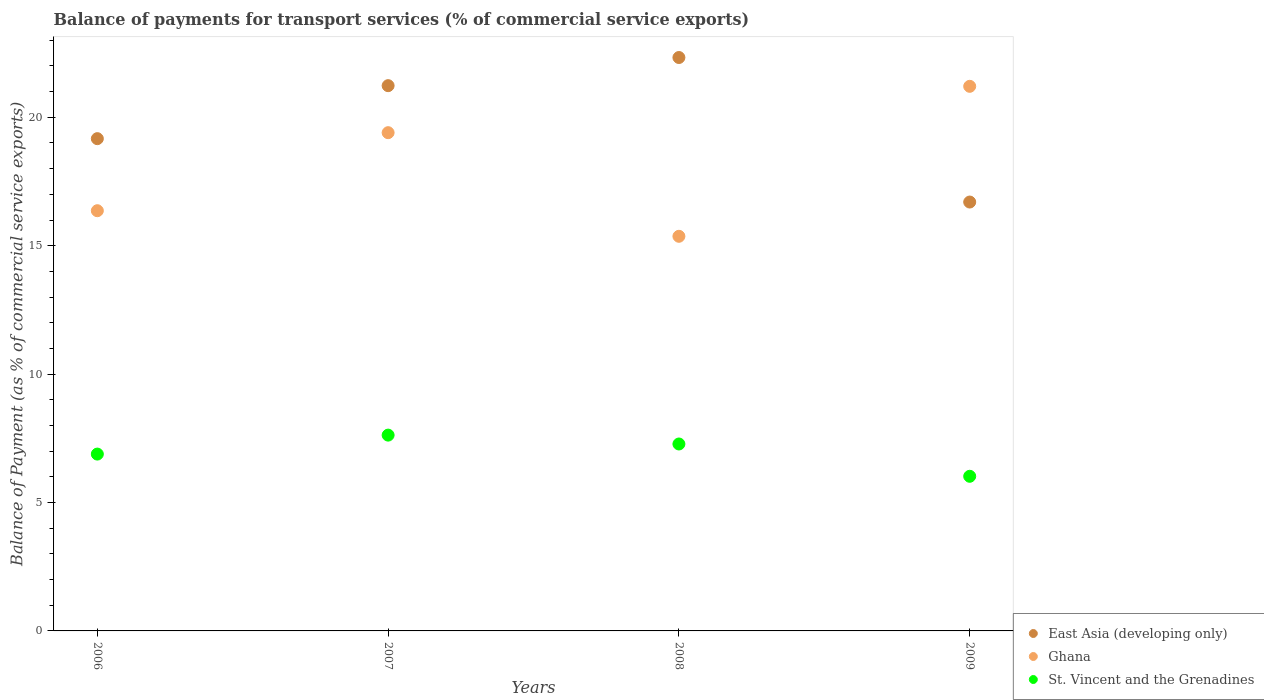How many different coloured dotlines are there?
Your response must be concise. 3. What is the balance of payments for transport services in East Asia (developing only) in 2007?
Give a very brief answer. 21.23. Across all years, what is the maximum balance of payments for transport services in Ghana?
Make the answer very short. 21.21. Across all years, what is the minimum balance of payments for transport services in East Asia (developing only)?
Provide a succinct answer. 16.7. In which year was the balance of payments for transport services in East Asia (developing only) maximum?
Your response must be concise. 2008. In which year was the balance of payments for transport services in Ghana minimum?
Ensure brevity in your answer.  2008. What is the total balance of payments for transport services in East Asia (developing only) in the graph?
Provide a short and direct response. 79.43. What is the difference between the balance of payments for transport services in East Asia (developing only) in 2006 and that in 2007?
Offer a very short reply. -2.06. What is the difference between the balance of payments for transport services in St. Vincent and the Grenadines in 2006 and the balance of payments for transport services in Ghana in 2008?
Offer a very short reply. -8.48. What is the average balance of payments for transport services in Ghana per year?
Offer a terse response. 18.08. In the year 2007, what is the difference between the balance of payments for transport services in Ghana and balance of payments for transport services in St. Vincent and the Grenadines?
Your answer should be very brief. 11.78. What is the ratio of the balance of payments for transport services in St. Vincent and the Grenadines in 2006 to that in 2009?
Your answer should be very brief. 1.14. Is the difference between the balance of payments for transport services in Ghana in 2006 and 2007 greater than the difference between the balance of payments for transport services in St. Vincent and the Grenadines in 2006 and 2007?
Offer a terse response. No. What is the difference between the highest and the second highest balance of payments for transport services in Ghana?
Keep it short and to the point. 1.81. What is the difference between the highest and the lowest balance of payments for transport services in Ghana?
Make the answer very short. 5.84. In how many years, is the balance of payments for transport services in East Asia (developing only) greater than the average balance of payments for transport services in East Asia (developing only) taken over all years?
Provide a short and direct response. 2. Is the sum of the balance of payments for transport services in St. Vincent and the Grenadines in 2006 and 2008 greater than the maximum balance of payments for transport services in East Asia (developing only) across all years?
Offer a terse response. No. Is the balance of payments for transport services in St. Vincent and the Grenadines strictly greater than the balance of payments for transport services in East Asia (developing only) over the years?
Provide a succinct answer. No. What is the difference between two consecutive major ticks on the Y-axis?
Ensure brevity in your answer.  5. Are the values on the major ticks of Y-axis written in scientific E-notation?
Give a very brief answer. No. Where does the legend appear in the graph?
Offer a terse response. Bottom right. What is the title of the graph?
Make the answer very short. Balance of payments for transport services (% of commercial service exports). What is the label or title of the X-axis?
Provide a succinct answer. Years. What is the label or title of the Y-axis?
Your answer should be compact. Balance of Payment (as % of commercial service exports). What is the Balance of Payment (as % of commercial service exports) of East Asia (developing only) in 2006?
Offer a very short reply. 19.17. What is the Balance of Payment (as % of commercial service exports) of Ghana in 2006?
Your answer should be very brief. 16.36. What is the Balance of Payment (as % of commercial service exports) in St. Vincent and the Grenadines in 2006?
Your response must be concise. 6.89. What is the Balance of Payment (as % of commercial service exports) of East Asia (developing only) in 2007?
Provide a short and direct response. 21.23. What is the Balance of Payment (as % of commercial service exports) of Ghana in 2007?
Your answer should be very brief. 19.4. What is the Balance of Payment (as % of commercial service exports) of St. Vincent and the Grenadines in 2007?
Keep it short and to the point. 7.62. What is the Balance of Payment (as % of commercial service exports) of East Asia (developing only) in 2008?
Provide a succinct answer. 22.33. What is the Balance of Payment (as % of commercial service exports) of Ghana in 2008?
Offer a very short reply. 15.37. What is the Balance of Payment (as % of commercial service exports) in St. Vincent and the Grenadines in 2008?
Keep it short and to the point. 7.28. What is the Balance of Payment (as % of commercial service exports) in East Asia (developing only) in 2009?
Your response must be concise. 16.7. What is the Balance of Payment (as % of commercial service exports) of Ghana in 2009?
Offer a terse response. 21.21. What is the Balance of Payment (as % of commercial service exports) of St. Vincent and the Grenadines in 2009?
Your answer should be very brief. 6.02. Across all years, what is the maximum Balance of Payment (as % of commercial service exports) of East Asia (developing only)?
Ensure brevity in your answer.  22.33. Across all years, what is the maximum Balance of Payment (as % of commercial service exports) of Ghana?
Provide a short and direct response. 21.21. Across all years, what is the maximum Balance of Payment (as % of commercial service exports) of St. Vincent and the Grenadines?
Provide a succinct answer. 7.62. Across all years, what is the minimum Balance of Payment (as % of commercial service exports) in East Asia (developing only)?
Provide a short and direct response. 16.7. Across all years, what is the minimum Balance of Payment (as % of commercial service exports) of Ghana?
Keep it short and to the point. 15.37. Across all years, what is the minimum Balance of Payment (as % of commercial service exports) in St. Vincent and the Grenadines?
Your answer should be very brief. 6.02. What is the total Balance of Payment (as % of commercial service exports) of East Asia (developing only) in the graph?
Keep it short and to the point. 79.43. What is the total Balance of Payment (as % of commercial service exports) in Ghana in the graph?
Keep it short and to the point. 72.34. What is the total Balance of Payment (as % of commercial service exports) in St. Vincent and the Grenadines in the graph?
Offer a terse response. 27.81. What is the difference between the Balance of Payment (as % of commercial service exports) in East Asia (developing only) in 2006 and that in 2007?
Ensure brevity in your answer.  -2.06. What is the difference between the Balance of Payment (as % of commercial service exports) in Ghana in 2006 and that in 2007?
Provide a succinct answer. -3.04. What is the difference between the Balance of Payment (as % of commercial service exports) of St. Vincent and the Grenadines in 2006 and that in 2007?
Give a very brief answer. -0.74. What is the difference between the Balance of Payment (as % of commercial service exports) in East Asia (developing only) in 2006 and that in 2008?
Keep it short and to the point. -3.16. What is the difference between the Balance of Payment (as % of commercial service exports) of Ghana in 2006 and that in 2008?
Your response must be concise. 1. What is the difference between the Balance of Payment (as % of commercial service exports) in St. Vincent and the Grenadines in 2006 and that in 2008?
Your answer should be very brief. -0.39. What is the difference between the Balance of Payment (as % of commercial service exports) of East Asia (developing only) in 2006 and that in 2009?
Your answer should be compact. 2.47. What is the difference between the Balance of Payment (as % of commercial service exports) of Ghana in 2006 and that in 2009?
Offer a terse response. -4.84. What is the difference between the Balance of Payment (as % of commercial service exports) of St. Vincent and the Grenadines in 2006 and that in 2009?
Offer a terse response. 0.86. What is the difference between the Balance of Payment (as % of commercial service exports) of East Asia (developing only) in 2007 and that in 2008?
Your answer should be compact. -1.1. What is the difference between the Balance of Payment (as % of commercial service exports) of Ghana in 2007 and that in 2008?
Your answer should be very brief. 4.04. What is the difference between the Balance of Payment (as % of commercial service exports) of St. Vincent and the Grenadines in 2007 and that in 2008?
Make the answer very short. 0.35. What is the difference between the Balance of Payment (as % of commercial service exports) in East Asia (developing only) in 2007 and that in 2009?
Your answer should be compact. 4.53. What is the difference between the Balance of Payment (as % of commercial service exports) of Ghana in 2007 and that in 2009?
Provide a succinct answer. -1.8. What is the difference between the Balance of Payment (as % of commercial service exports) in St. Vincent and the Grenadines in 2007 and that in 2009?
Provide a short and direct response. 1.6. What is the difference between the Balance of Payment (as % of commercial service exports) of East Asia (developing only) in 2008 and that in 2009?
Provide a short and direct response. 5.63. What is the difference between the Balance of Payment (as % of commercial service exports) of Ghana in 2008 and that in 2009?
Provide a short and direct response. -5.84. What is the difference between the Balance of Payment (as % of commercial service exports) in St. Vincent and the Grenadines in 2008 and that in 2009?
Your answer should be very brief. 1.26. What is the difference between the Balance of Payment (as % of commercial service exports) in East Asia (developing only) in 2006 and the Balance of Payment (as % of commercial service exports) in Ghana in 2007?
Keep it short and to the point. -0.23. What is the difference between the Balance of Payment (as % of commercial service exports) in East Asia (developing only) in 2006 and the Balance of Payment (as % of commercial service exports) in St. Vincent and the Grenadines in 2007?
Offer a terse response. 11.54. What is the difference between the Balance of Payment (as % of commercial service exports) of Ghana in 2006 and the Balance of Payment (as % of commercial service exports) of St. Vincent and the Grenadines in 2007?
Ensure brevity in your answer.  8.74. What is the difference between the Balance of Payment (as % of commercial service exports) in East Asia (developing only) in 2006 and the Balance of Payment (as % of commercial service exports) in Ghana in 2008?
Your answer should be compact. 3.8. What is the difference between the Balance of Payment (as % of commercial service exports) in East Asia (developing only) in 2006 and the Balance of Payment (as % of commercial service exports) in St. Vincent and the Grenadines in 2008?
Offer a terse response. 11.89. What is the difference between the Balance of Payment (as % of commercial service exports) in Ghana in 2006 and the Balance of Payment (as % of commercial service exports) in St. Vincent and the Grenadines in 2008?
Your answer should be compact. 9.08. What is the difference between the Balance of Payment (as % of commercial service exports) of East Asia (developing only) in 2006 and the Balance of Payment (as % of commercial service exports) of Ghana in 2009?
Make the answer very short. -2.04. What is the difference between the Balance of Payment (as % of commercial service exports) in East Asia (developing only) in 2006 and the Balance of Payment (as % of commercial service exports) in St. Vincent and the Grenadines in 2009?
Your response must be concise. 13.15. What is the difference between the Balance of Payment (as % of commercial service exports) of Ghana in 2006 and the Balance of Payment (as % of commercial service exports) of St. Vincent and the Grenadines in 2009?
Offer a very short reply. 10.34. What is the difference between the Balance of Payment (as % of commercial service exports) of East Asia (developing only) in 2007 and the Balance of Payment (as % of commercial service exports) of Ghana in 2008?
Offer a very short reply. 5.87. What is the difference between the Balance of Payment (as % of commercial service exports) in East Asia (developing only) in 2007 and the Balance of Payment (as % of commercial service exports) in St. Vincent and the Grenadines in 2008?
Keep it short and to the point. 13.95. What is the difference between the Balance of Payment (as % of commercial service exports) of Ghana in 2007 and the Balance of Payment (as % of commercial service exports) of St. Vincent and the Grenadines in 2008?
Give a very brief answer. 12.12. What is the difference between the Balance of Payment (as % of commercial service exports) in East Asia (developing only) in 2007 and the Balance of Payment (as % of commercial service exports) in Ghana in 2009?
Keep it short and to the point. 0.03. What is the difference between the Balance of Payment (as % of commercial service exports) of East Asia (developing only) in 2007 and the Balance of Payment (as % of commercial service exports) of St. Vincent and the Grenadines in 2009?
Your response must be concise. 15.21. What is the difference between the Balance of Payment (as % of commercial service exports) in Ghana in 2007 and the Balance of Payment (as % of commercial service exports) in St. Vincent and the Grenadines in 2009?
Keep it short and to the point. 13.38. What is the difference between the Balance of Payment (as % of commercial service exports) of East Asia (developing only) in 2008 and the Balance of Payment (as % of commercial service exports) of Ghana in 2009?
Provide a succinct answer. 1.12. What is the difference between the Balance of Payment (as % of commercial service exports) in East Asia (developing only) in 2008 and the Balance of Payment (as % of commercial service exports) in St. Vincent and the Grenadines in 2009?
Offer a terse response. 16.31. What is the difference between the Balance of Payment (as % of commercial service exports) of Ghana in 2008 and the Balance of Payment (as % of commercial service exports) of St. Vincent and the Grenadines in 2009?
Your answer should be very brief. 9.35. What is the average Balance of Payment (as % of commercial service exports) in East Asia (developing only) per year?
Make the answer very short. 19.86. What is the average Balance of Payment (as % of commercial service exports) in Ghana per year?
Ensure brevity in your answer.  18.08. What is the average Balance of Payment (as % of commercial service exports) in St. Vincent and the Grenadines per year?
Ensure brevity in your answer.  6.95. In the year 2006, what is the difference between the Balance of Payment (as % of commercial service exports) of East Asia (developing only) and Balance of Payment (as % of commercial service exports) of Ghana?
Provide a succinct answer. 2.81. In the year 2006, what is the difference between the Balance of Payment (as % of commercial service exports) in East Asia (developing only) and Balance of Payment (as % of commercial service exports) in St. Vincent and the Grenadines?
Provide a short and direct response. 12.28. In the year 2006, what is the difference between the Balance of Payment (as % of commercial service exports) in Ghana and Balance of Payment (as % of commercial service exports) in St. Vincent and the Grenadines?
Offer a terse response. 9.48. In the year 2007, what is the difference between the Balance of Payment (as % of commercial service exports) of East Asia (developing only) and Balance of Payment (as % of commercial service exports) of Ghana?
Provide a succinct answer. 1.83. In the year 2007, what is the difference between the Balance of Payment (as % of commercial service exports) of East Asia (developing only) and Balance of Payment (as % of commercial service exports) of St. Vincent and the Grenadines?
Keep it short and to the point. 13.61. In the year 2007, what is the difference between the Balance of Payment (as % of commercial service exports) of Ghana and Balance of Payment (as % of commercial service exports) of St. Vincent and the Grenadines?
Your response must be concise. 11.78. In the year 2008, what is the difference between the Balance of Payment (as % of commercial service exports) in East Asia (developing only) and Balance of Payment (as % of commercial service exports) in Ghana?
Provide a short and direct response. 6.96. In the year 2008, what is the difference between the Balance of Payment (as % of commercial service exports) of East Asia (developing only) and Balance of Payment (as % of commercial service exports) of St. Vincent and the Grenadines?
Give a very brief answer. 15.05. In the year 2008, what is the difference between the Balance of Payment (as % of commercial service exports) of Ghana and Balance of Payment (as % of commercial service exports) of St. Vincent and the Grenadines?
Provide a short and direct response. 8.09. In the year 2009, what is the difference between the Balance of Payment (as % of commercial service exports) in East Asia (developing only) and Balance of Payment (as % of commercial service exports) in Ghana?
Provide a succinct answer. -4.51. In the year 2009, what is the difference between the Balance of Payment (as % of commercial service exports) of East Asia (developing only) and Balance of Payment (as % of commercial service exports) of St. Vincent and the Grenadines?
Your answer should be very brief. 10.68. In the year 2009, what is the difference between the Balance of Payment (as % of commercial service exports) of Ghana and Balance of Payment (as % of commercial service exports) of St. Vincent and the Grenadines?
Offer a terse response. 15.19. What is the ratio of the Balance of Payment (as % of commercial service exports) of East Asia (developing only) in 2006 to that in 2007?
Your answer should be very brief. 0.9. What is the ratio of the Balance of Payment (as % of commercial service exports) in Ghana in 2006 to that in 2007?
Make the answer very short. 0.84. What is the ratio of the Balance of Payment (as % of commercial service exports) of St. Vincent and the Grenadines in 2006 to that in 2007?
Provide a short and direct response. 0.9. What is the ratio of the Balance of Payment (as % of commercial service exports) in East Asia (developing only) in 2006 to that in 2008?
Your response must be concise. 0.86. What is the ratio of the Balance of Payment (as % of commercial service exports) of Ghana in 2006 to that in 2008?
Give a very brief answer. 1.06. What is the ratio of the Balance of Payment (as % of commercial service exports) in St. Vincent and the Grenadines in 2006 to that in 2008?
Ensure brevity in your answer.  0.95. What is the ratio of the Balance of Payment (as % of commercial service exports) of East Asia (developing only) in 2006 to that in 2009?
Your response must be concise. 1.15. What is the ratio of the Balance of Payment (as % of commercial service exports) of Ghana in 2006 to that in 2009?
Provide a succinct answer. 0.77. What is the ratio of the Balance of Payment (as % of commercial service exports) of St. Vincent and the Grenadines in 2006 to that in 2009?
Make the answer very short. 1.14. What is the ratio of the Balance of Payment (as % of commercial service exports) of East Asia (developing only) in 2007 to that in 2008?
Offer a very short reply. 0.95. What is the ratio of the Balance of Payment (as % of commercial service exports) in Ghana in 2007 to that in 2008?
Your response must be concise. 1.26. What is the ratio of the Balance of Payment (as % of commercial service exports) in St. Vincent and the Grenadines in 2007 to that in 2008?
Keep it short and to the point. 1.05. What is the ratio of the Balance of Payment (as % of commercial service exports) in East Asia (developing only) in 2007 to that in 2009?
Keep it short and to the point. 1.27. What is the ratio of the Balance of Payment (as % of commercial service exports) in Ghana in 2007 to that in 2009?
Your answer should be compact. 0.91. What is the ratio of the Balance of Payment (as % of commercial service exports) of St. Vincent and the Grenadines in 2007 to that in 2009?
Provide a succinct answer. 1.27. What is the ratio of the Balance of Payment (as % of commercial service exports) in East Asia (developing only) in 2008 to that in 2009?
Your answer should be compact. 1.34. What is the ratio of the Balance of Payment (as % of commercial service exports) in Ghana in 2008 to that in 2009?
Your answer should be compact. 0.72. What is the ratio of the Balance of Payment (as % of commercial service exports) of St. Vincent and the Grenadines in 2008 to that in 2009?
Ensure brevity in your answer.  1.21. What is the difference between the highest and the second highest Balance of Payment (as % of commercial service exports) in East Asia (developing only)?
Your response must be concise. 1.1. What is the difference between the highest and the second highest Balance of Payment (as % of commercial service exports) in Ghana?
Your answer should be very brief. 1.8. What is the difference between the highest and the second highest Balance of Payment (as % of commercial service exports) in St. Vincent and the Grenadines?
Provide a succinct answer. 0.35. What is the difference between the highest and the lowest Balance of Payment (as % of commercial service exports) in East Asia (developing only)?
Your response must be concise. 5.63. What is the difference between the highest and the lowest Balance of Payment (as % of commercial service exports) of Ghana?
Give a very brief answer. 5.84. What is the difference between the highest and the lowest Balance of Payment (as % of commercial service exports) in St. Vincent and the Grenadines?
Offer a terse response. 1.6. 